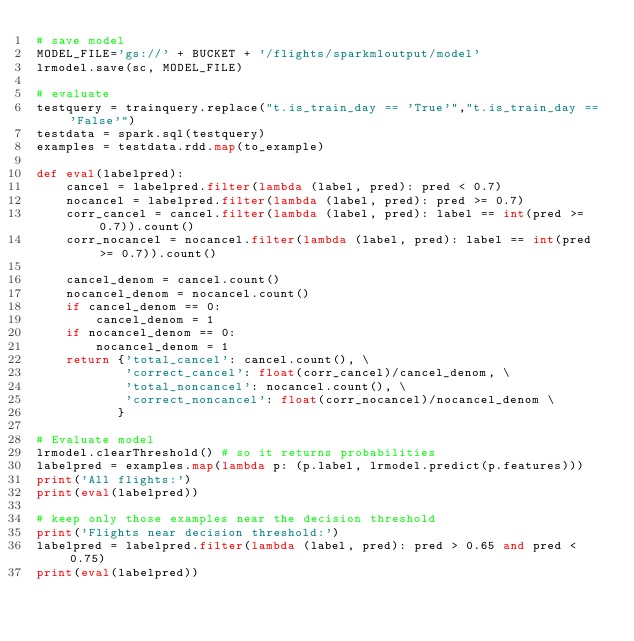<code> <loc_0><loc_0><loc_500><loc_500><_Python_># save model
MODEL_FILE='gs://' + BUCKET + '/flights/sparkmloutput/model'
lrmodel.save(sc, MODEL_FILE)

# evaluate
testquery = trainquery.replace("t.is_train_day == 'True'","t.is_train_day == 'False'")
testdata = spark.sql(testquery)
examples = testdata.rdd.map(to_example)

def eval(labelpred):
    cancel = labelpred.filter(lambda (label, pred): pred < 0.7)
    nocancel = labelpred.filter(lambda (label, pred): pred >= 0.7)
    corr_cancel = cancel.filter(lambda (label, pred): label == int(pred >= 0.7)).count()
    corr_nocancel = nocancel.filter(lambda (label, pred): label == int(pred >= 0.7)).count()
    
    cancel_denom = cancel.count()
    nocancel_denom = nocancel.count()
    if cancel_denom == 0:
        cancel_denom = 1
    if nocancel_denom == 0:
        nocancel_denom = 1
    return {'total_cancel': cancel.count(), \
            'correct_cancel': float(corr_cancel)/cancel_denom, \
            'total_noncancel': nocancel.count(), \
            'correct_noncancel': float(corr_nocancel)/nocancel_denom \
           }

# Evaluate model
lrmodel.clearThreshold() # so it returns probabilities
labelpred = examples.map(lambda p: (p.label, lrmodel.predict(p.features)))
print('All flights:')
print(eval(labelpred))

# keep only those examples near the decision threshold
print('Flights near decision threshold:')
labelpred = labelpred.filter(lambda (label, pred): pred > 0.65 and pred < 0.75)
print(eval(labelpred))

</code> 